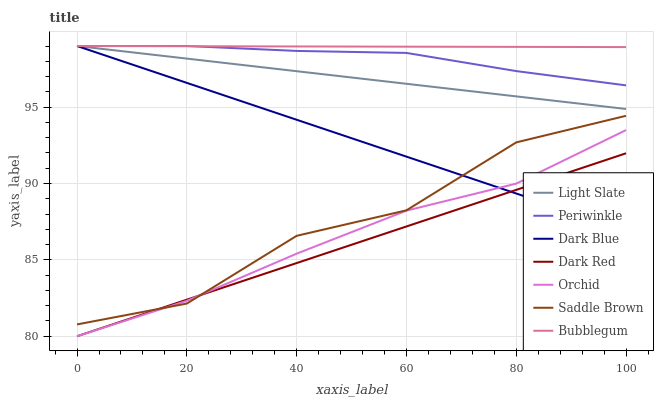Does Dark Red have the minimum area under the curve?
Answer yes or no. Yes. Does Bubblegum have the maximum area under the curve?
Answer yes or no. Yes. Does Bubblegum have the minimum area under the curve?
Answer yes or no. No. Does Dark Red have the maximum area under the curve?
Answer yes or no. No. Is Dark Red the smoothest?
Answer yes or no. Yes. Is Saddle Brown the roughest?
Answer yes or no. Yes. Is Bubblegum the smoothest?
Answer yes or no. No. Is Bubblegum the roughest?
Answer yes or no. No. Does Bubblegum have the lowest value?
Answer yes or no. No. Does Periwinkle have the highest value?
Answer yes or no. Yes. Does Dark Red have the highest value?
Answer yes or no. No. Is Saddle Brown less than Periwinkle?
Answer yes or no. Yes. Is Bubblegum greater than Saddle Brown?
Answer yes or no. Yes. Does Dark Red intersect Orchid?
Answer yes or no. Yes. Is Dark Red less than Orchid?
Answer yes or no. No. Is Dark Red greater than Orchid?
Answer yes or no. No. Does Saddle Brown intersect Periwinkle?
Answer yes or no. No. 